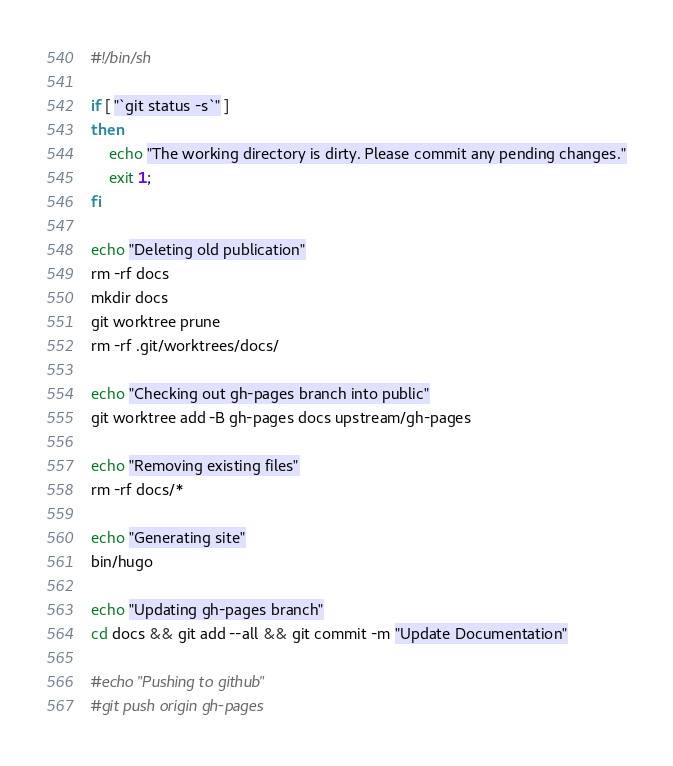<code> <loc_0><loc_0><loc_500><loc_500><_Bash_>#!/bin/sh

if [ "`git status -s`" ]
then
    echo "The working directory is dirty. Please commit any pending changes."
    exit 1;
fi

echo "Deleting old publication"
rm -rf docs
mkdir docs
git worktree prune
rm -rf .git/worktrees/docs/

echo "Checking out gh-pages branch into public"
git worktree add -B gh-pages docs upstream/gh-pages

echo "Removing existing files"
rm -rf docs/*

echo "Generating site"
bin/hugo

echo "Updating gh-pages branch"
cd docs && git add --all && git commit -m "Update Documentation"

#echo "Pushing to github"
#git push origin gh-pages
</code> 